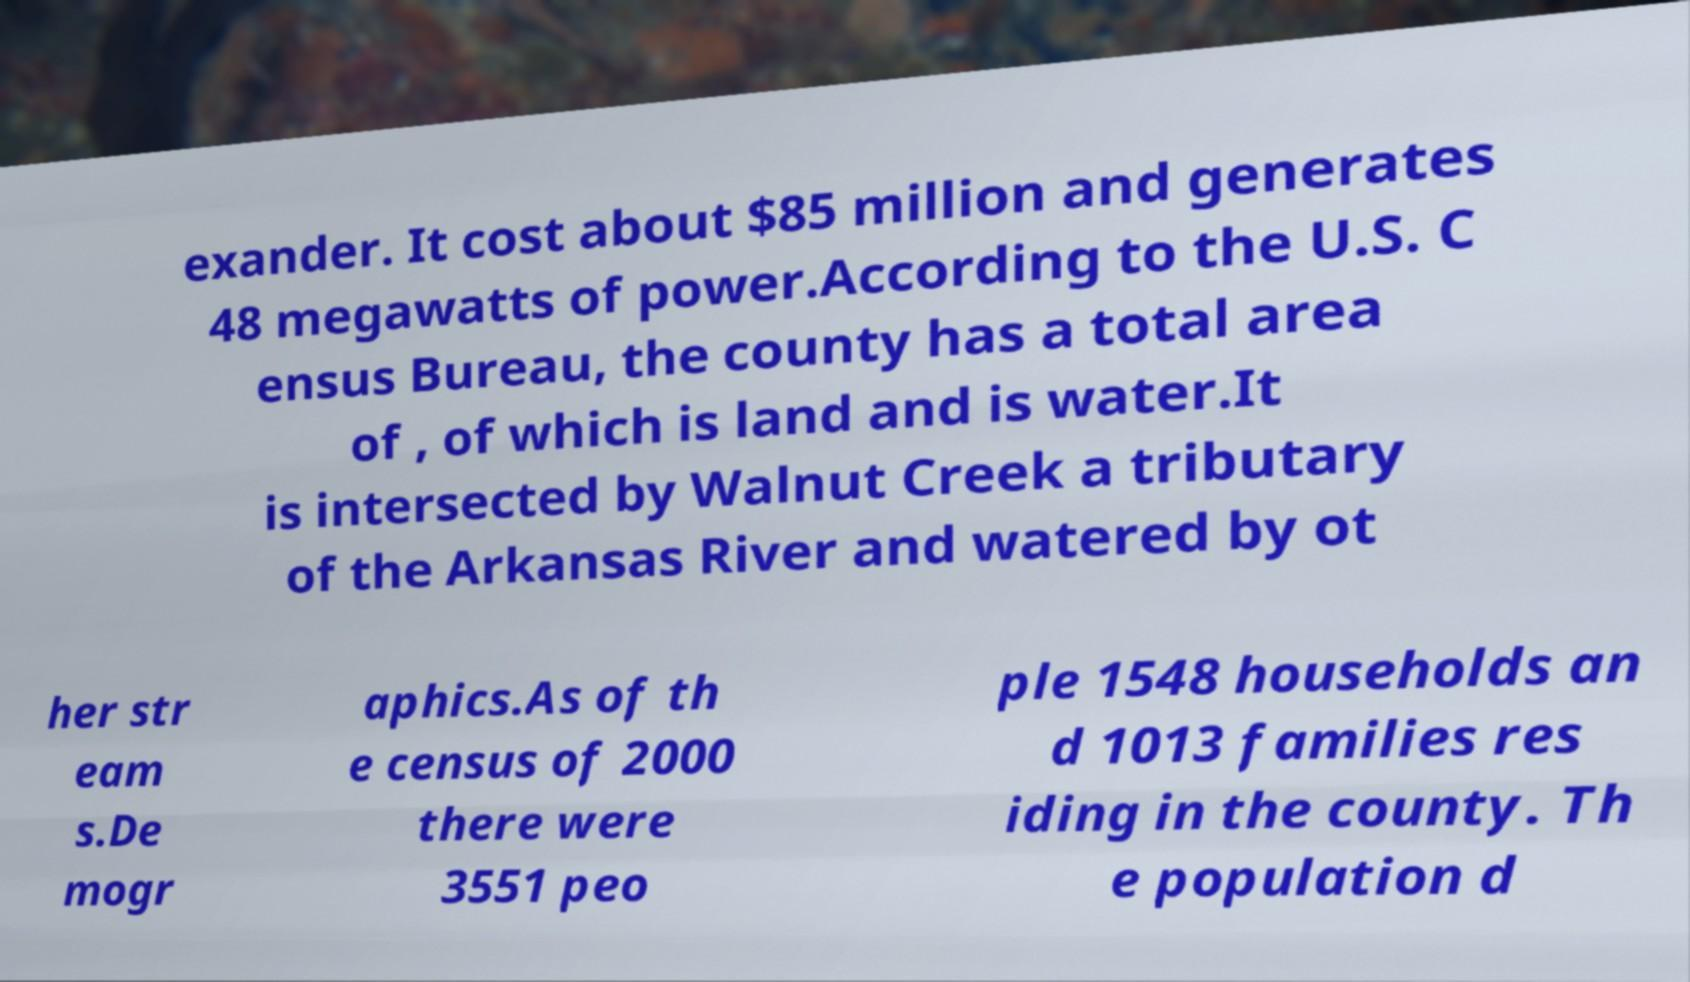There's text embedded in this image that I need extracted. Can you transcribe it verbatim? exander. It cost about $85 million and generates 48 megawatts of power.According to the U.S. C ensus Bureau, the county has a total area of , of which is land and is water.It is intersected by Walnut Creek a tributary of the Arkansas River and watered by ot her str eam s.De mogr aphics.As of th e census of 2000 there were 3551 peo ple 1548 households an d 1013 families res iding in the county. Th e population d 